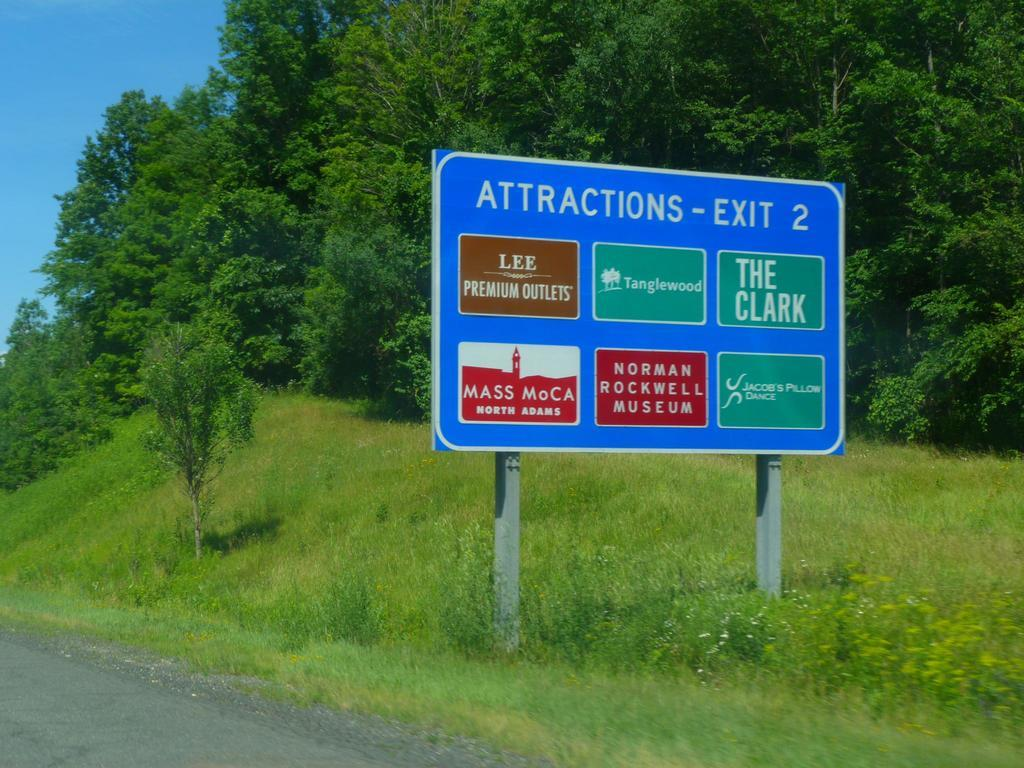<image>
Summarize the visual content of the image. A sign for Attractions at Exit 2 including Lee Premium Outlets and the Norman Rockwell Museum. 